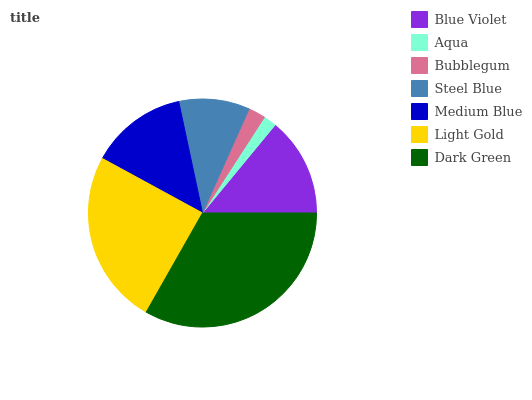Is Aqua the minimum?
Answer yes or no. Yes. Is Dark Green the maximum?
Answer yes or no. Yes. Is Bubblegum the minimum?
Answer yes or no. No. Is Bubblegum the maximum?
Answer yes or no. No. Is Bubblegum greater than Aqua?
Answer yes or no. Yes. Is Aqua less than Bubblegum?
Answer yes or no. Yes. Is Aqua greater than Bubblegum?
Answer yes or no. No. Is Bubblegum less than Aqua?
Answer yes or no. No. Is Medium Blue the high median?
Answer yes or no. Yes. Is Medium Blue the low median?
Answer yes or no. Yes. Is Light Gold the high median?
Answer yes or no. No. Is Steel Blue the low median?
Answer yes or no. No. 